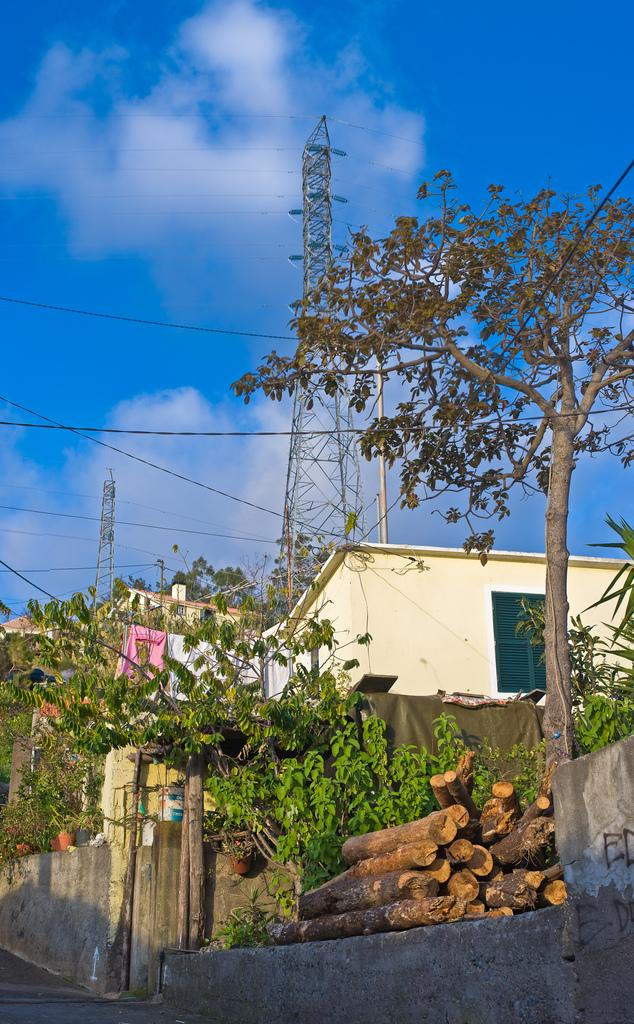What type of natural elements can be seen in the image? There are plants, logs, and trees in the image. What type of man-made structures are present in the image? There are towers, buildings, and wires in the image. What is visible in the background of the image? The sky is visible in the background of the image, and there are clouds in the sky. How many feet are visible in the image? There are no feet present in the image. What type of farm animals can be seen grazing in the image? There are no farm animals present in the image. 